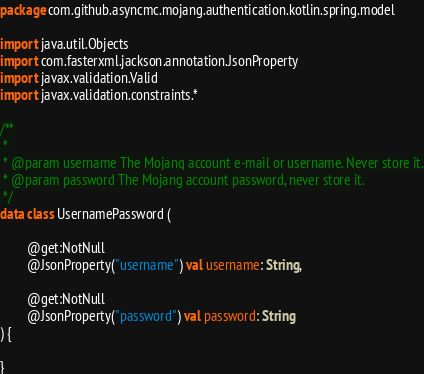Convert code to text. <code><loc_0><loc_0><loc_500><loc_500><_Kotlin_>package com.github.asyncmc.mojang.authentication.kotlin.spring.model

import java.util.Objects
import com.fasterxml.jackson.annotation.JsonProperty
import javax.validation.Valid
import javax.validation.constraints.*

/**
 * 
 * @param username The Mojang account e-mail or username. Never store it.
 * @param password The Mojang account password, never store it.
 */
data class UsernamePassword (

        @get:NotNull 
        @JsonProperty("username") val username: String,

        @get:NotNull 
        @JsonProperty("password") val password: String
) {

}

</code> 